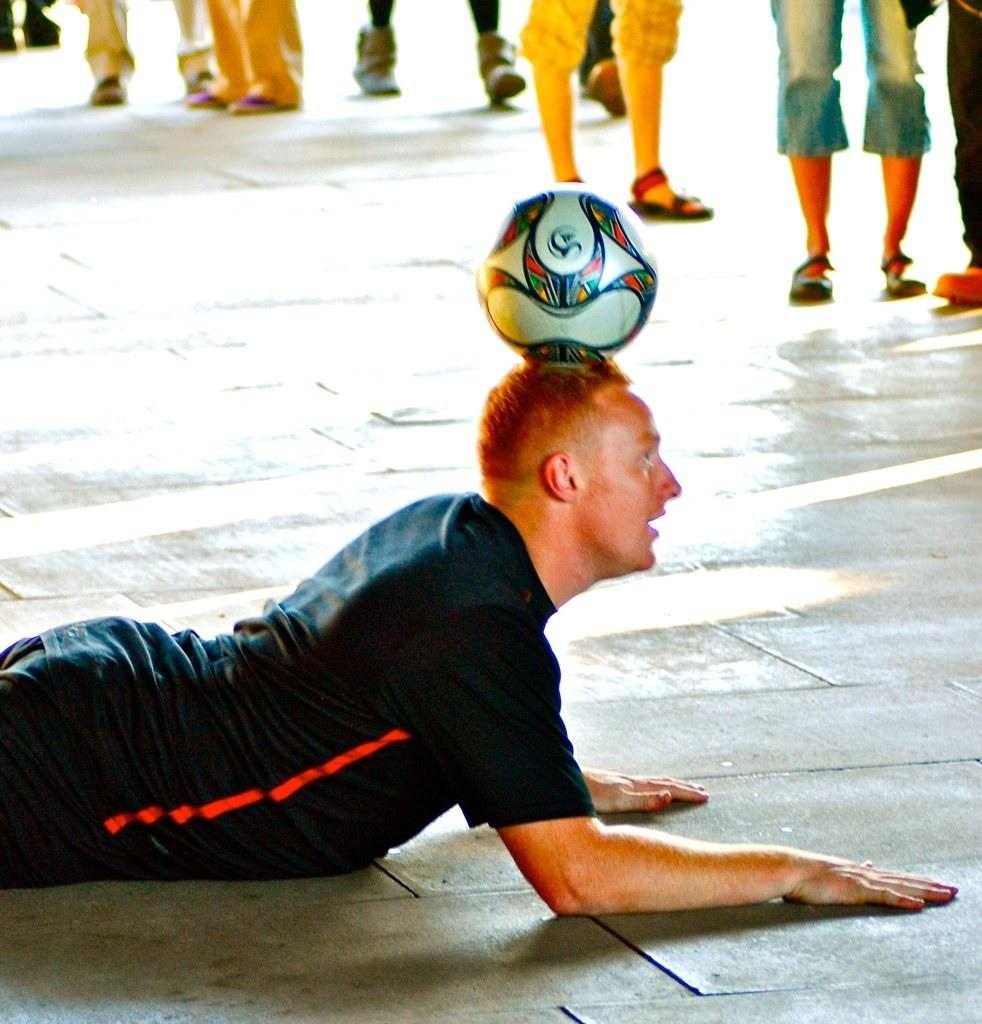What is the position of the man in the image? The man is laying on the floor in the image. What is on the man's head? There is a ball on the man's head. What are the other people in the image doing? Some people are standing, and some are walking in the image. What flavor of ice cream is being served on the plate in the image? There is no plate or ice cream present in the image. 